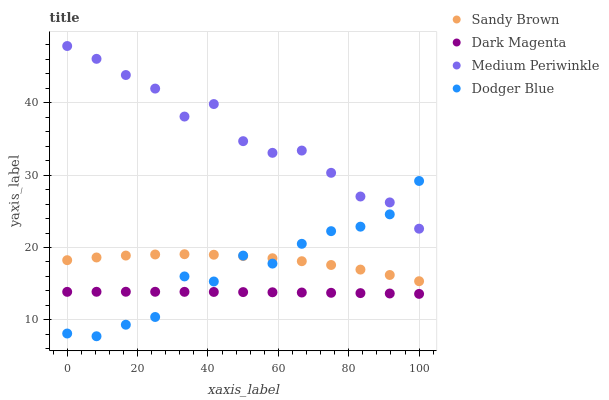Does Dark Magenta have the minimum area under the curve?
Answer yes or no. Yes. Does Medium Periwinkle have the maximum area under the curve?
Answer yes or no. Yes. Does Sandy Brown have the minimum area under the curve?
Answer yes or no. No. Does Sandy Brown have the maximum area under the curve?
Answer yes or no. No. Is Dark Magenta the smoothest?
Answer yes or no. Yes. Is Dodger Blue the roughest?
Answer yes or no. Yes. Is Sandy Brown the smoothest?
Answer yes or no. No. Is Sandy Brown the roughest?
Answer yes or no. No. Does Dodger Blue have the lowest value?
Answer yes or no. Yes. Does Sandy Brown have the lowest value?
Answer yes or no. No. Does Medium Periwinkle have the highest value?
Answer yes or no. Yes. Does Sandy Brown have the highest value?
Answer yes or no. No. Is Sandy Brown less than Medium Periwinkle?
Answer yes or no. Yes. Is Sandy Brown greater than Dark Magenta?
Answer yes or no. Yes. Does Dark Magenta intersect Dodger Blue?
Answer yes or no. Yes. Is Dark Magenta less than Dodger Blue?
Answer yes or no. No. Is Dark Magenta greater than Dodger Blue?
Answer yes or no. No. Does Sandy Brown intersect Medium Periwinkle?
Answer yes or no. No. 